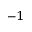<formula> <loc_0><loc_0><loc_500><loc_500>^ { - 1 }</formula> 